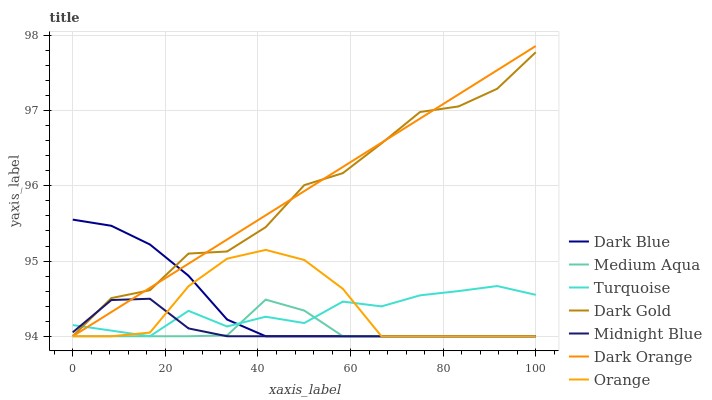Does Medium Aqua have the minimum area under the curve?
Answer yes or no. Yes. Does Dark Orange have the maximum area under the curve?
Answer yes or no. Yes. Does Turquoise have the minimum area under the curve?
Answer yes or no. No. Does Turquoise have the maximum area under the curve?
Answer yes or no. No. Is Dark Orange the smoothest?
Answer yes or no. Yes. Is Dark Gold the roughest?
Answer yes or no. Yes. Is Turquoise the smoothest?
Answer yes or no. No. Is Turquoise the roughest?
Answer yes or no. No. Does Dark Orange have the lowest value?
Answer yes or no. Yes. Does Dark Orange have the highest value?
Answer yes or no. Yes. Does Turquoise have the highest value?
Answer yes or no. No. Does Dark Gold intersect Medium Aqua?
Answer yes or no. Yes. Is Dark Gold less than Medium Aqua?
Answer yes or no. No. Is Dark Gold greater than Medium Aqua?
Answer yes or no. No. 